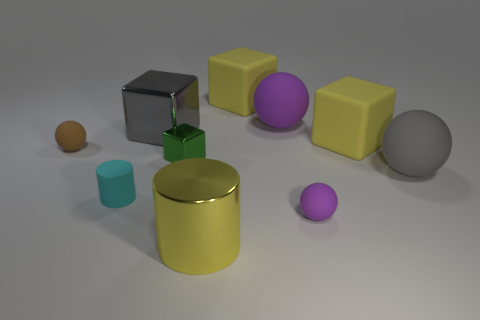The sphere that is the same color as the large metal cube is what size?
Offer a terse response. Large. What number of things are either brown objects or gray rubber balls?
Offer a very short reply. 2. The big gray object that is left of the purple thing in front of the tiny brown matte thing is made of what material?
Make the answer very short. Metal. Is there a large matte object of the same color as the large metal cube?
Your answer should be very brief. Yes. There is a cylinder that is the same size as the green shiny thing; what color is it?
Your answer should be very brief. Cyan. What material is the gray thing that is to the right of the large yellow matte cube right of the tiny rubber thing right of the large metal cube made of?
Your answer should be very brief. Rubber. Is the color of the big cylinder the same as the cube to the right of the small purple rubber ball?
Provide a short and direct response. Yes. What number of things are either tiny rubber spheres that are behind the gray rubber object or big things that are behind the brown matte sphere?
Keep it short and to the point. 5. There is a large yellow matte thing that is to the left of the purple matte sphere in front of the large gray rubber object; what is its shape?
Make the answer very short. Cube. Is there a brown thing that has the same material as the cyan object?
Offer a very short reply. Yes. 